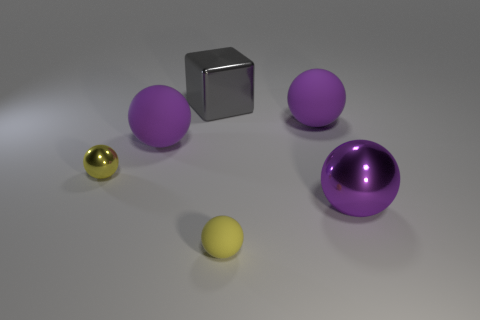Add 2 small blue rubber spheres. How many objects exist? 8 Subtract all big matte spheres. How many spheres are left? 3 Subtract all yellow spheres. How many spheres are left? 3 Subtract 1 cubes. How many cubes are left? 0 Add 1 small metallic spheres. How many small metallic spheres are left? 2 Add 1 cyan cylinders. How many cyan cylinders exist? 1 Subtract 0 gray balls. How many objects are left? 6 Subtract all balls. How many objects are left? 1 Subtract all brown cubes. Subtract all gray balls. How many cubes are left? 1 Subtract all red blocks. How many purple balls are left? 3 